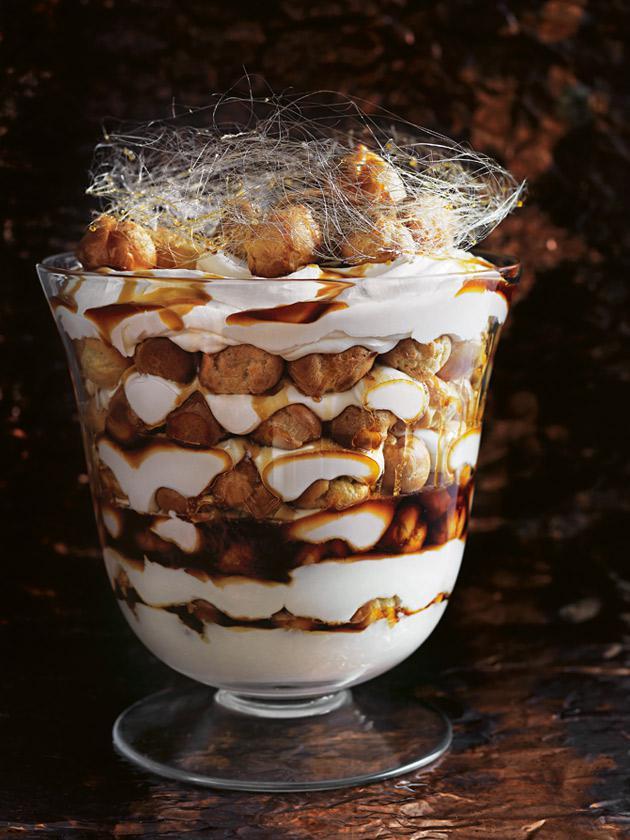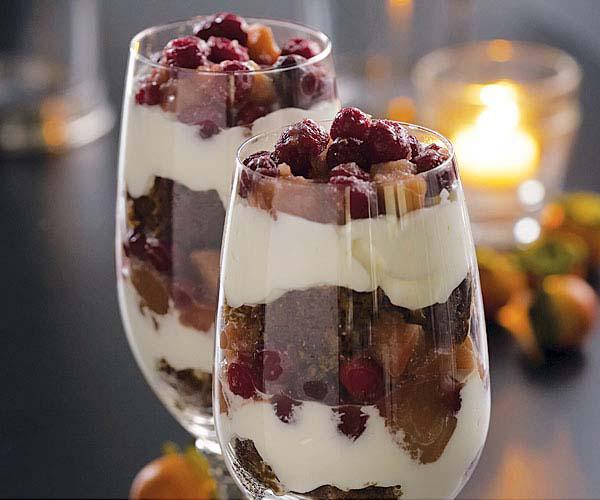The first image is the image on the left, the second image is the image on the right. Assess this claim about the two images: "1 of the images has 1 candle in the background.". Correct or not? Answer yes or no. Yes. 